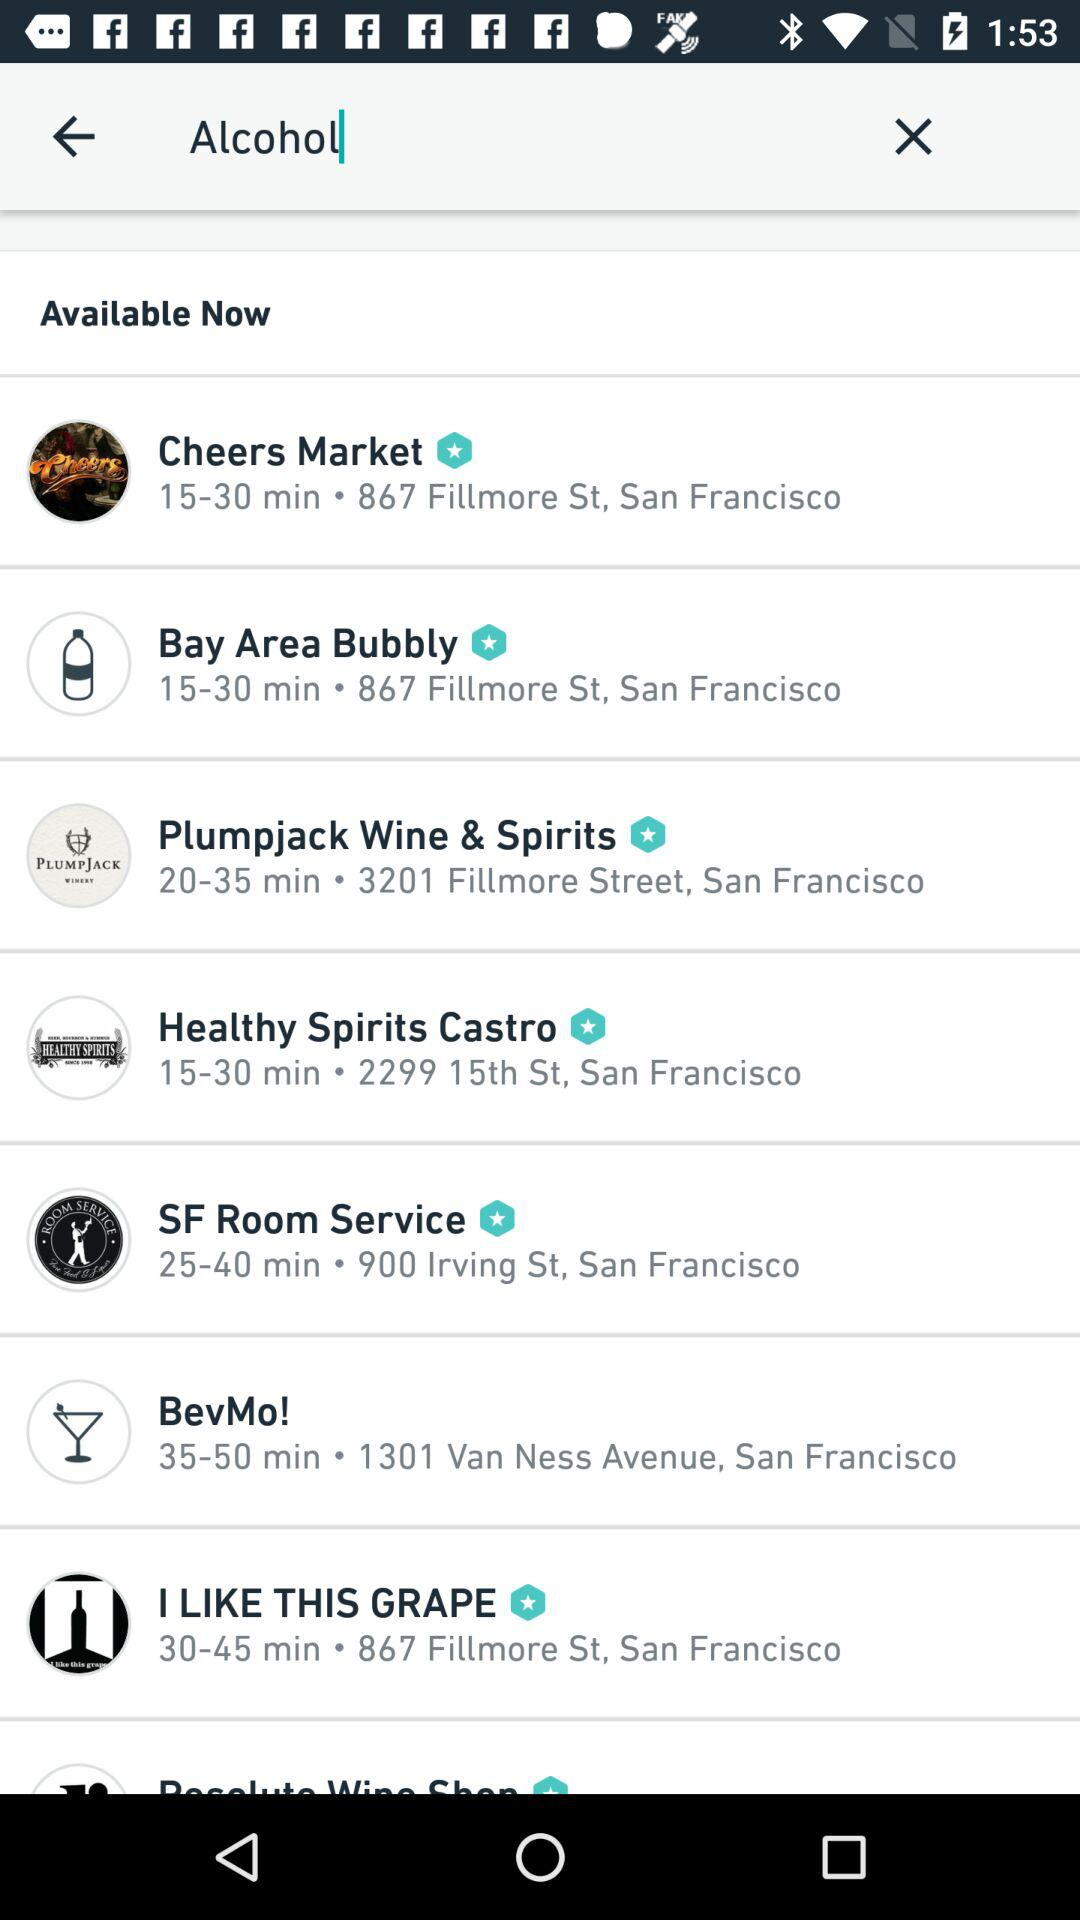How far is the Bay Area Bubbly?
When the provided information is insufficient, respond with <no answer>. <no answer> 